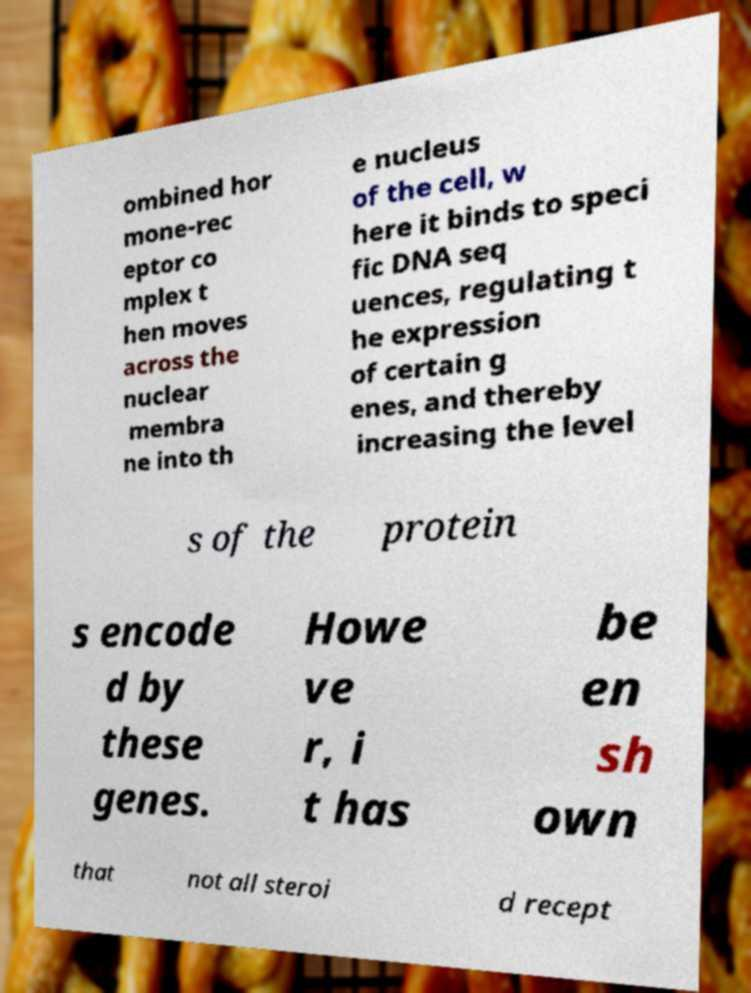Could you extract and type out the text from this image? ombined hor mone-rec eptor co mplex t hen moves across the nuclear membra ne into th e nucleus of the cell, w here it binds to speci fic DNA seq uences, regulating t he expression of certain g enes, and thereby increasing the level s of the protein s encode d by these genes. Howe ve r, i t has be en sh own that not all steroi d recept 